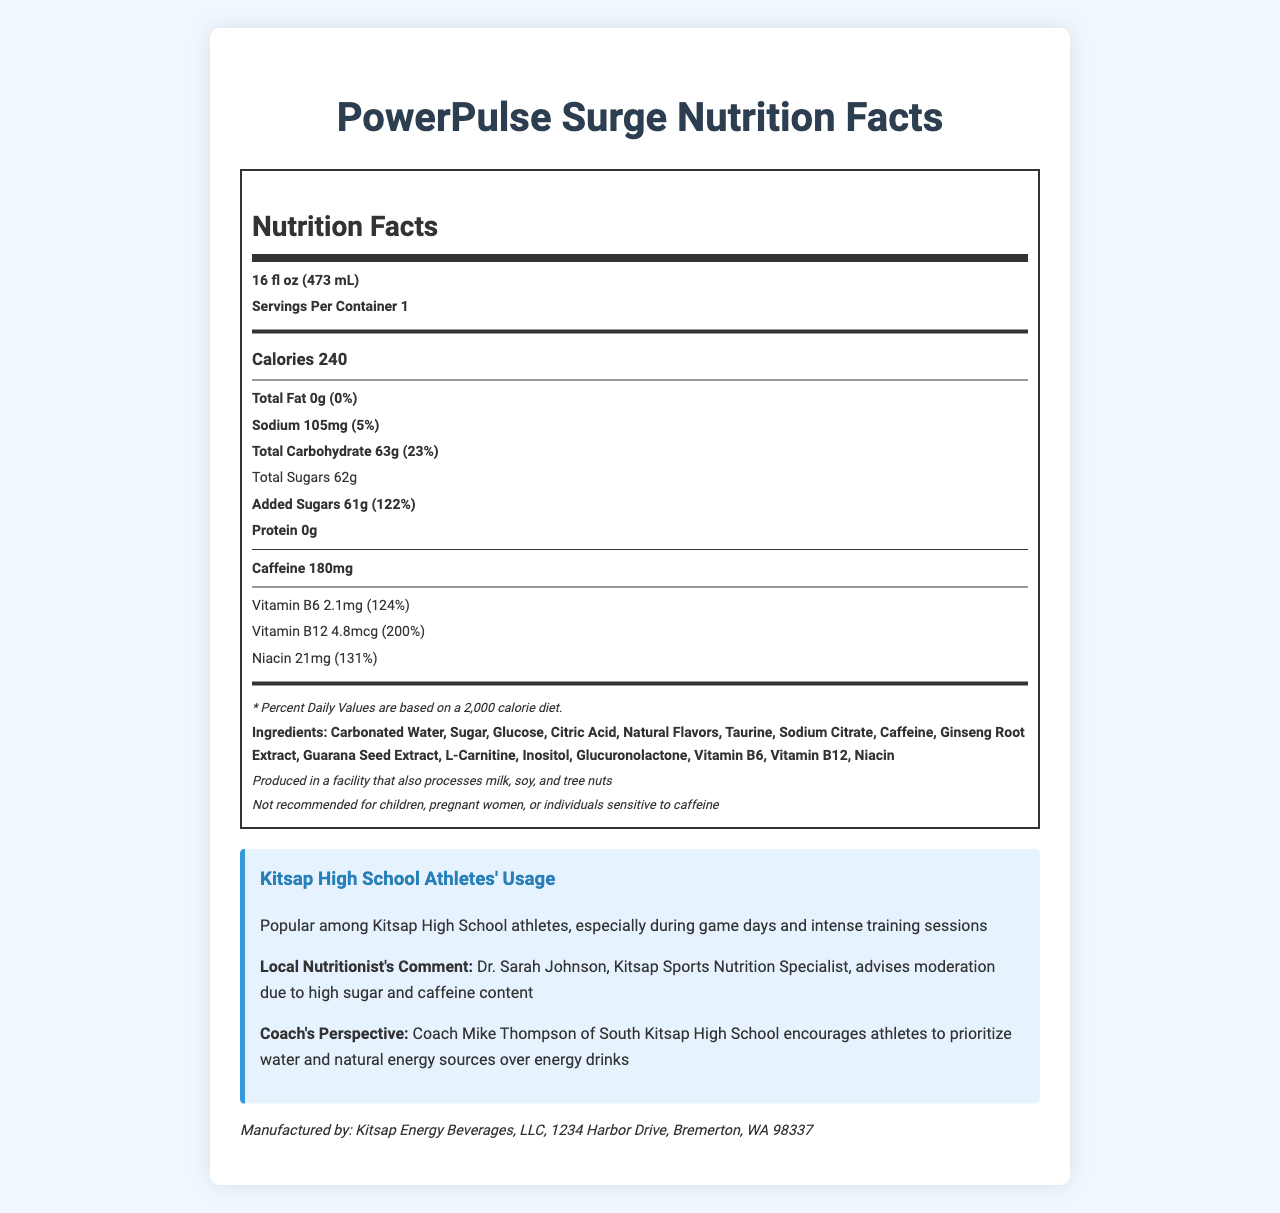what is the caffeine content of PowerPulse Surge? The nutrition facts section of the document explicitly lists caffeine content as 180mg.
Answer: 180mg how many calories does one serving of PowerPulse Surge contain? The calories are mentioned in the large bold text under the nutrition facts section.
Answer: 240 what percentage of the daily value of added sugars does PowerPulse Surge provide? The document states that the added sugars content is 61g, which constitutes 122% of the daily value.
Answer: 122% what ingredients are used in PowerPulse Surge? The ingredients are listed in the nutrition facts section under the ingredients subsection.
Answer: Carbonated Water, Sugar, Glucose, Citric Acid, Natural Flavors, Taurine, Sodium Citrate, Caffeine, Ginseng Root Extract, Guarana Seed Extract, L-Carnitine, Inositol, Glucuronolactone, Vitamin B6, Vitamin B12, Niacin who manufactures PowerPulse Surge? The manufacturer information is located at the bottom of the document.
Answer: Kitsap Energy Beverages, LLC how much sodium is in one serving of PowerPulse Surge? The sodium content is mentioned in the nutrition facts section under the sodium subsection.
Answer: 105mg what is the serving size of PowerPulse Surge? The serving size is listed at the top of the nutrition facts section.
Answer: 16 fl oz (473 mL) which vitamin has the highest percentage of daily value in PowerPulse Surge? Vitamin B12 has a daily value percentage of 200%, which is the highest among the listed vitamins and minerals.
Answer: Vitamin B12 what is the recommended number of servings per container for PowerPulse Surge? A. 1 B. 2 C. 3 D. 4 The document indicates that there is 1 serving per container.
Answer: A which of the following is not an ingredient in PowerPulse Surge? I. Glucose II. Aspartame III. Guarana Seed Extract IV. Citric Acid  A. I B. II C. III D. IV Aspartame is not listed as an ingredient in PowerPulse Surge; the other ingredients are listed.
Answer: B is PowerPulse Surge recommended for children and pregnant women? The disclaimer explicitly states that it is not recommended for children, pregnant women, or individuals sensitive to caffeine.
Answer: No summarize the main idea of the document The document provides a comprehensive description of PowerPulse Surge's nutritional information, ingredient list, and advice from local experts, highlighting its popularity among high school athletes in Kitsap.
Answer: A nutrition facts label for PowerPulse Surge, an energy drink, detailing its serving size, calories, fat, sodium, carbohydrate, sugar, protein, and caffeine content. It lists ingredients, allergen information, and usage among Kitsap High School athletes. Local nutritionists and coaches provide advice on its consumption. what is the price of PowerPulse Surge? The document does not mention the price of PowerPulse Surge.
Answer: Not enough information how much total carbohydrate does PowerPulse Surge contain per serving? The total carbohydrate content is listed in the nutrition facts section under the total carbohydrate subsection.
Answer: 63g 